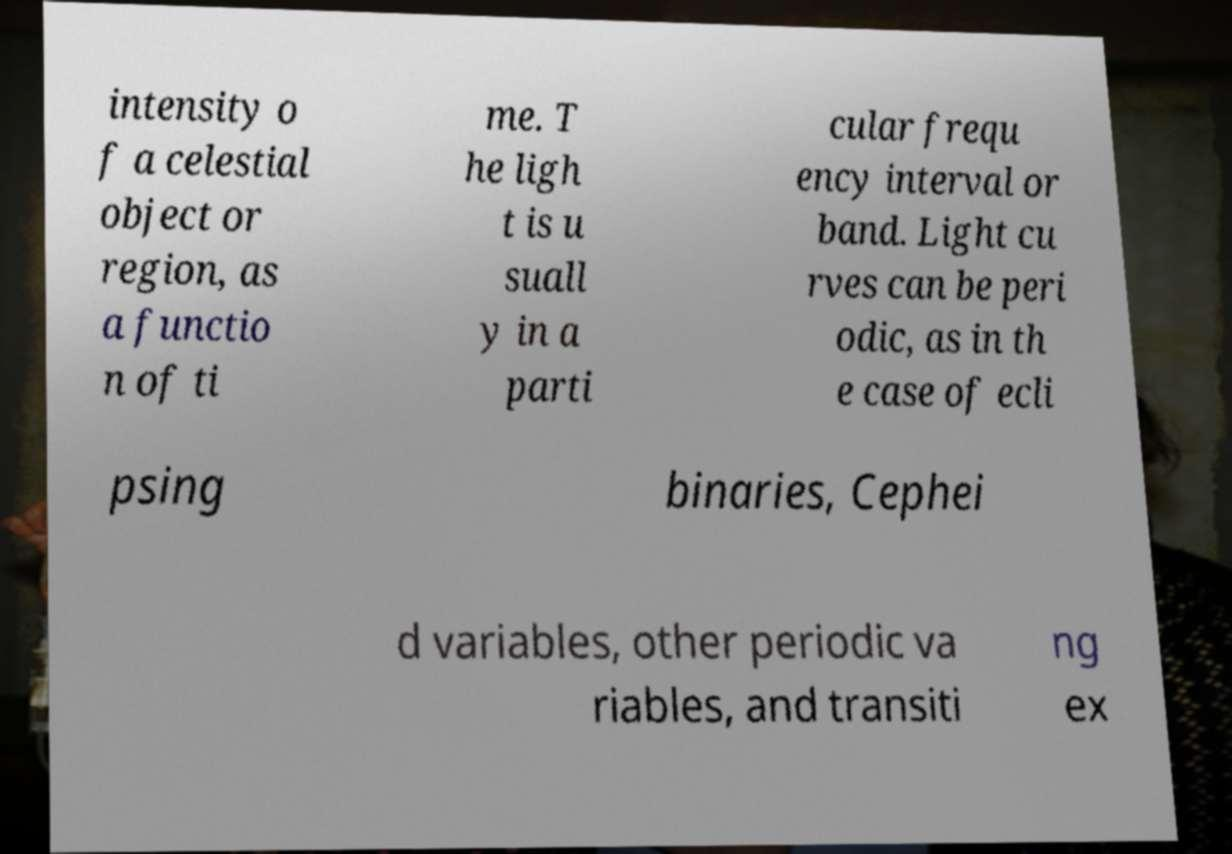There's text embedded in this image that I need extracted. Can you transcribe it verbatim? intensity o f a celestial object or region, as a functio n of ti me. T he ligh t is u suall y in a parti cular frequ ency interval or band. Light cu rves can be peri odic, as in th e case of ecli psing binaries, Cephei d variables, other periodic va riables, and transiti ng ex 